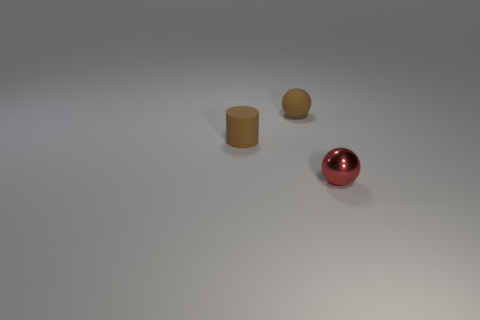What time of day does the lighting in the image suggest? The lighting in the image appears to be artificial and diffuse, mimicking what might be an indoor setting. There are no clear indicators of a natural light source such as the sun to provide clues about the time of day. 